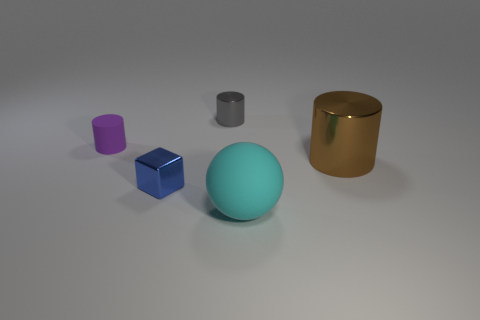What is the color of the matte cylinder that is the same size as the blue block?
Offer a terse response. Purple. Are there any other things that are the same shape as the small rubber thing?
Provide a succinct answer. Yes. There is another small metallic thing that is the same shape as the small purple thing; what is its color?
Offer a very short reply. Gray. What number of objects are large green cylinders or cylinders that are on the left side of the large cyan thing?
Offer a very short reply. 2. Is the number of cyan matte spheres that are in front of the matte sphere less than the number of purple rubber cylinders?
Make the answer very short. Yes. How big is the metal thing that is behind the metallic cylinder that is on the right side of the shiny cylinder behind the big brown thing?
Provide a short and direct response. Small. What color is the object that is both in front of the big brown cylinder and to the left of the gray metallic cylinder?
Ensure brevity in your answer.  Blue. What number of blue metal blocks are there?
Provide a succinct answer. 1. Do the gray cylinder and the brown object have the same material?
Give a very brief answer. Yes. There is a rubber thing right of the tiny blue shiny cube; is its size the same as the metal thing on the right side of the big cyan rubber thing?
Provide a succinct answer. Yes. 